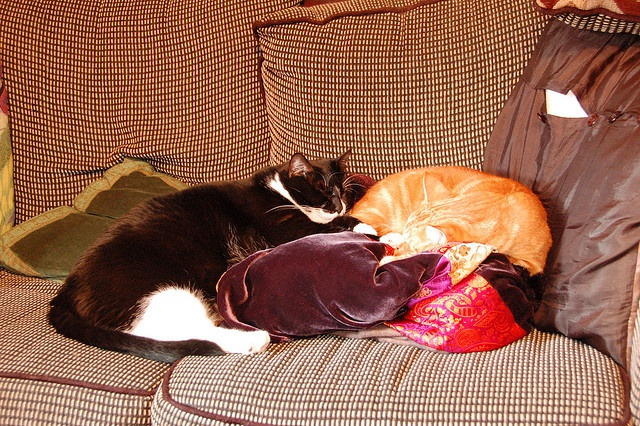Describe the objects in this image and their specific colors. I can see couch in maroon, brown, and tan tones and cat in maroon, black, and white tones in this image. 